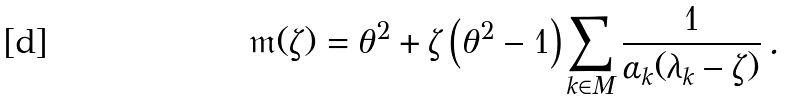<formula> <loc_0><loc_0><loc_500><loc_500>\mathfrak { m } ( \zeta ) = \theta ^ { 2 } + \zeta \left ( \theta ^ { 2 } - 1 \right ) \sum _ { k \in M } \frac { 1 } { \alpha _ { k } ( \lambda _ { k } - \zeta ) } \, .</formula> 